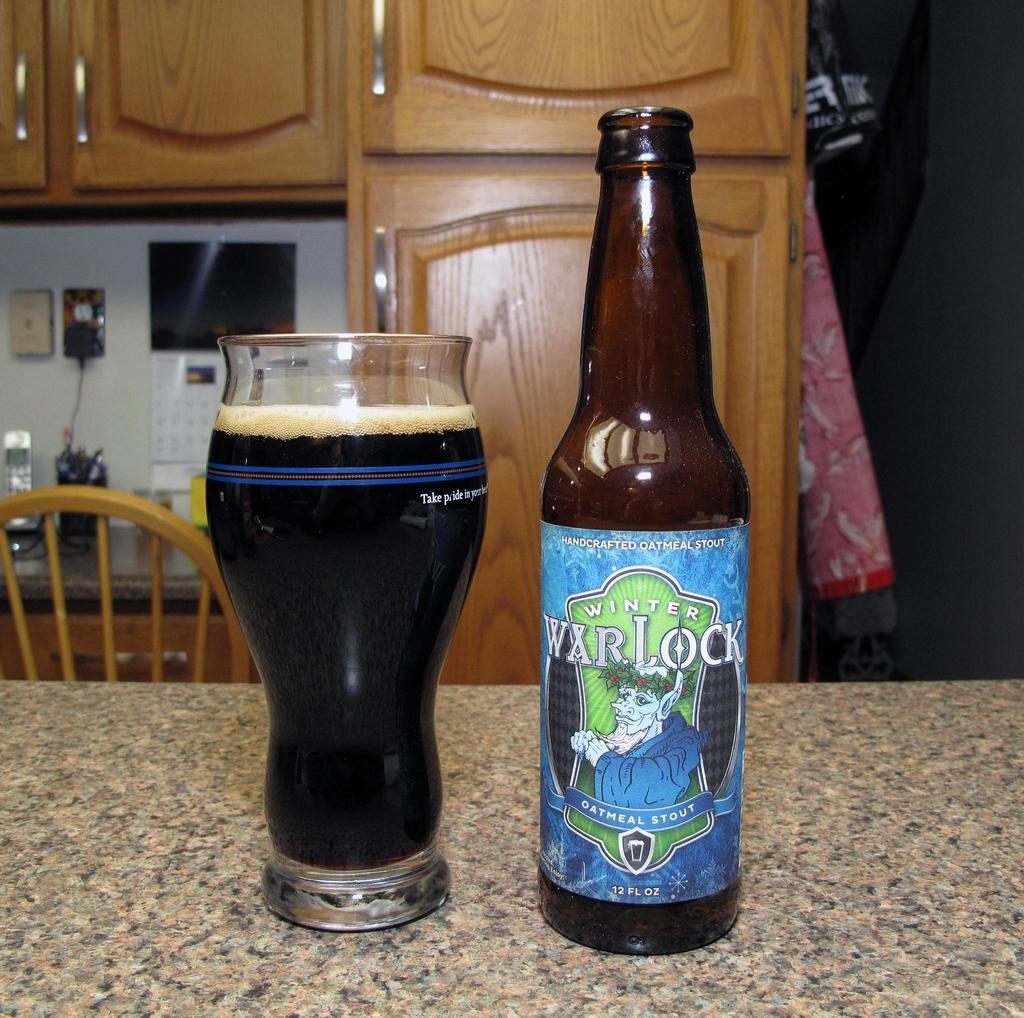Provide a one-sentence caption for the provided image. A glass and a beer bottle reading War Lock. 